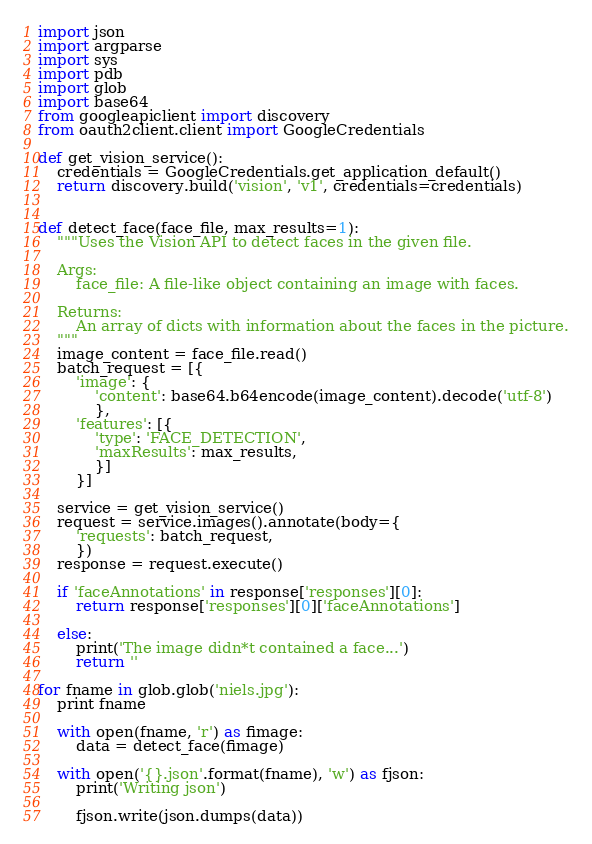<code> <loc_0><loc_0><loc_500><loc_500><_Python_>import json
import argparse
import sys
import pdb
import glob
import base64
from googleapiclient import discovery
from oauth2client.client import GoogleCredentials

def get_vision_service():
    credentials = GoogleCredentials.get_application_default()
    return discovery.build('vision', 'v1', credentials=credentials)


def detect_face(face_file, max_results=1):
    """Uses the Vision API to detect faces in the given file.

    Args:
        face_file: A file-like object containing an image with faces.

    Returns:
        An array of dicts with information about the faces in the picture.
    """
    image_content = face_file.read()
    batch_request = [{
        'image': {
            'content': base64.b64encode(image_content).decode('utf-8')
            },
        'features': [{
            'type': 'FACE_DETECTION',
            'maxResults': max_results,
            }]
        }]

    service = get_vision_service()
    request = service.images().annotate(body={
        'requests': batch_request,
        })
    response = request.execute()

    if 'faceAnnotations' in response['responses'][0]:
        return response['responses'][0]['faceAnnotations']

    else:
        print('The image didn*t contained a face...')
        return ''

for fname in glob.glob('niels.jpg'):
    print fname

    with open(fname, 'r') as fimage:
        data = detect_face(fimage)

    with open('{}.json'.format(fname), 'w') as fjson:
        print('Writing json')

        fjson.write(json.dumps(data))
</code> 